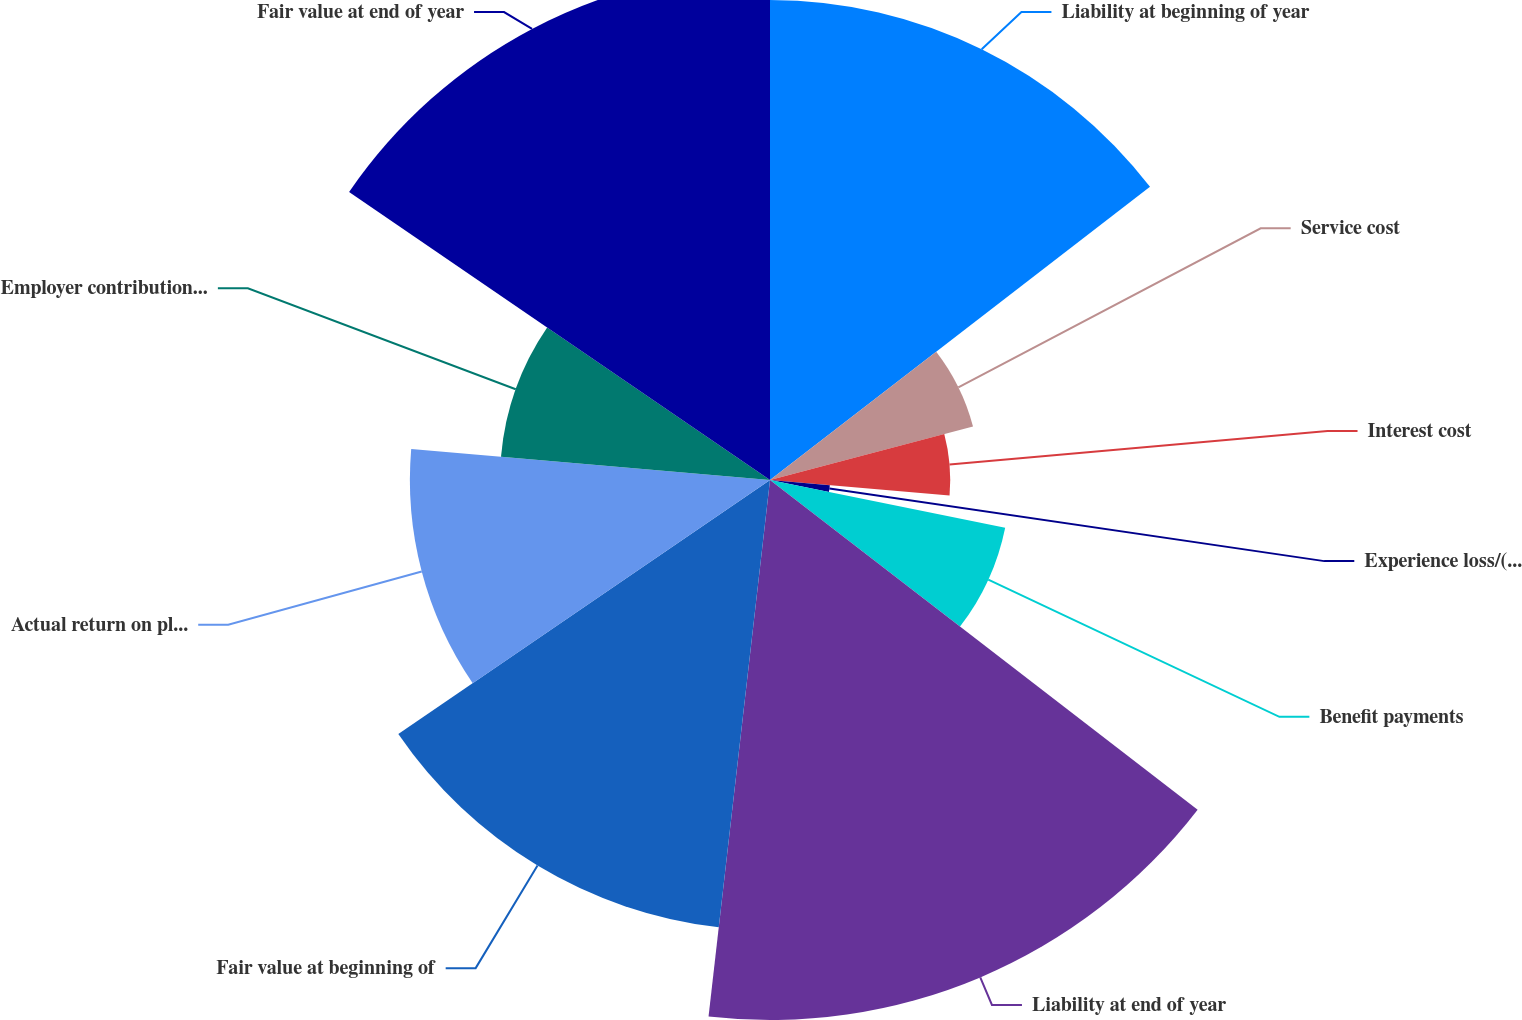Convert chart. <chart><loc_0><loc_0><loc_500><loc_500><pie_chart><fcel>Liability at beginning of year<fcel>Service cost<fcel>Interest cost<fcel>Experience loss/(gain)<fcel>Benefit payments<fcel>Liability at end of year<fcel>Fair value at beginning of<fcel>Actual return on plan assets<fcel>Employer contributions/funding<fcel>Fair value at end of year<nl><fcel>14.54%<fcel>6.36%<fcel>5.46%<fcel>1.82%<fcel>7.27%<fcel>16.36%<fcel>13.64%<fcel>10.91%<fcel>8.18%<fcel>15.45%<nl></chart> 